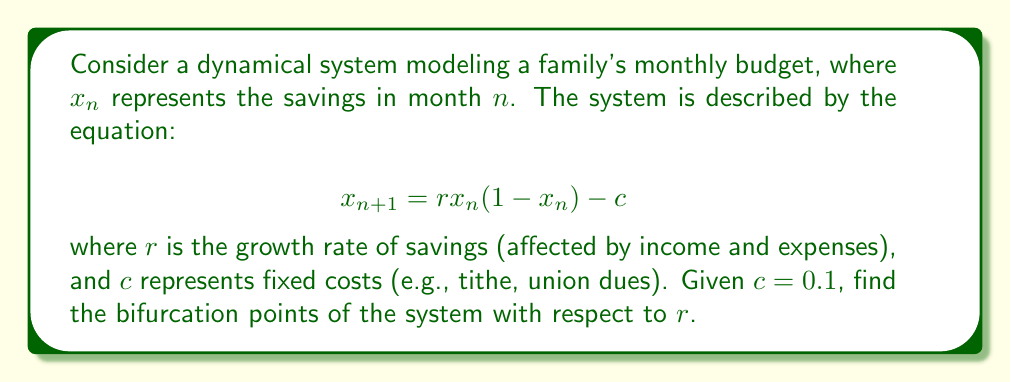Can you solve this math problem? To find the bifurcation points, we need to follow these steps:

1) First, find the fixed points of the system by solving:
   $$x = rx(1-x) - c$$

2) Rearrange the equation:
   $$rx^2 - rx + x + c = 0$$

3) This is a quadratic equation in the form $ax^2 + bx + d = 0$, where:
   $a = r$
   $b = -r + 1$
   $d = c = 0.1$

4) For bifurcation to occur, the discriminant of this quadratic equation should be zero. The discriminant is given by $b^2 - 4ad = 0$.

5) Substitute the values:
   $$(−r + 1)^2 - 4r(0.1) = 0$$

6) Expand:
   $$r^2 - 2r + 1 - 0.4r = 0$$
   $$r^2 - 2.4r + 1 = 0$$

7) This is a quadratic in $r$. Solve using the quadratic formula:
   $$r = \frac{2.4 \pm \sqrt{2.4^2 - 4(1)(1)}}{2(1)}$$

8) Simplify:
   $$r = \frac{2.4 \pm \sqrt{5.76 - 4}}{2} = \frac{2.4 \pm \sqrt{1.76}}{2}$$

9) Calculate the final values:
   $$r \approx 2.0 \text{ or } r \approx 0.4$$

These values of $r$ are the bifurcation points of the system.
Answer: $r \approx 2.0$ and $r \approx 0.4$ 